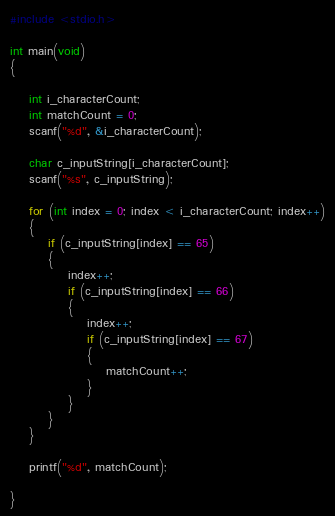Convert code to text. <code><loc_0><loc_0><loc_500><loc_500><_C_>#include <stdio.h>

int main(void)
{

    int i_characterCount;
    int matchCount = 0;
    scanf("%d", &i_characterCount);

    char c_inputString[i_characterCount];
    scanf("%s", c_inputString);

    for (int index = 0; index < i_characterCount; index++)
    {
        if (c_inputString[index] == 65)
        {
            index++;
            if (c_inputString[index] == 66)
            {
                index++;
                if (c_inputString[index] == 67)
                {
                    matchCount++;
                }
            }
        }
    }

    printf("%d", matchCount);

}</code> 